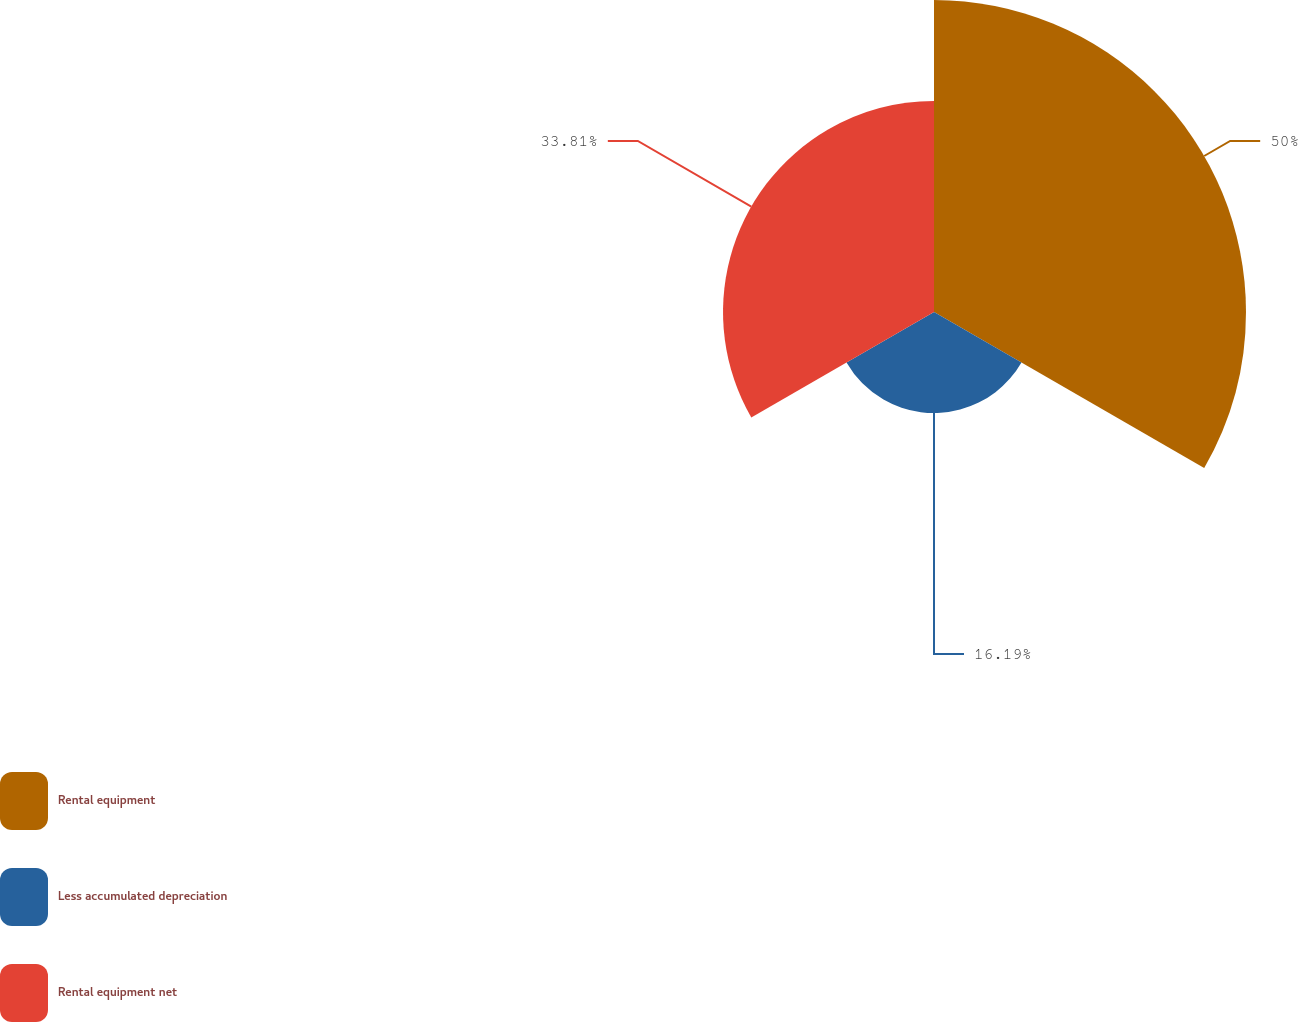Convert chart. <chart><loc_0><loc_0><loc_500><loc_500><pie_chart><fcel>Rental equipment<fcel>Less accumulated depreciation<fcel>Rental equipment net<nl><fcel>50.0%<fcel>16.19%<fcel>33.81%<nl></chart> 